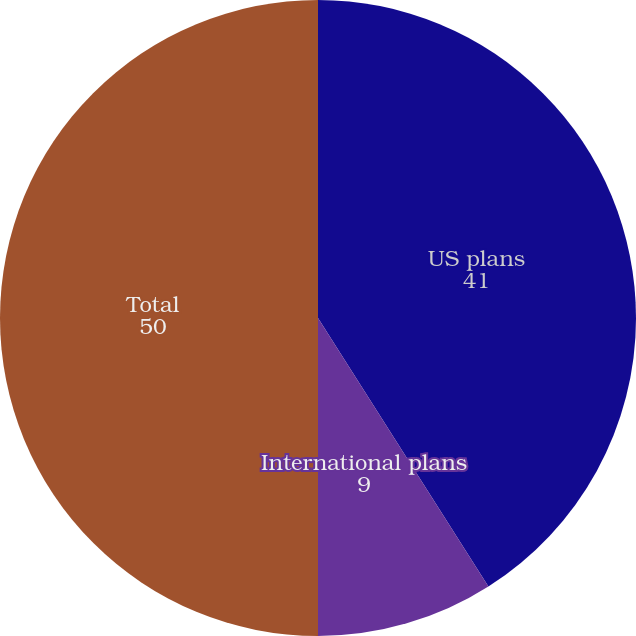Convert chart to OTSL. <chart><loc_0><loc_0><loc_500><loc_500><pie_chart><fcel>US plans<fcel>International plans<fcel>Total<nl><fcel>41.0%<fcel>9.0%<fcel>50.0%<nl></chart> 